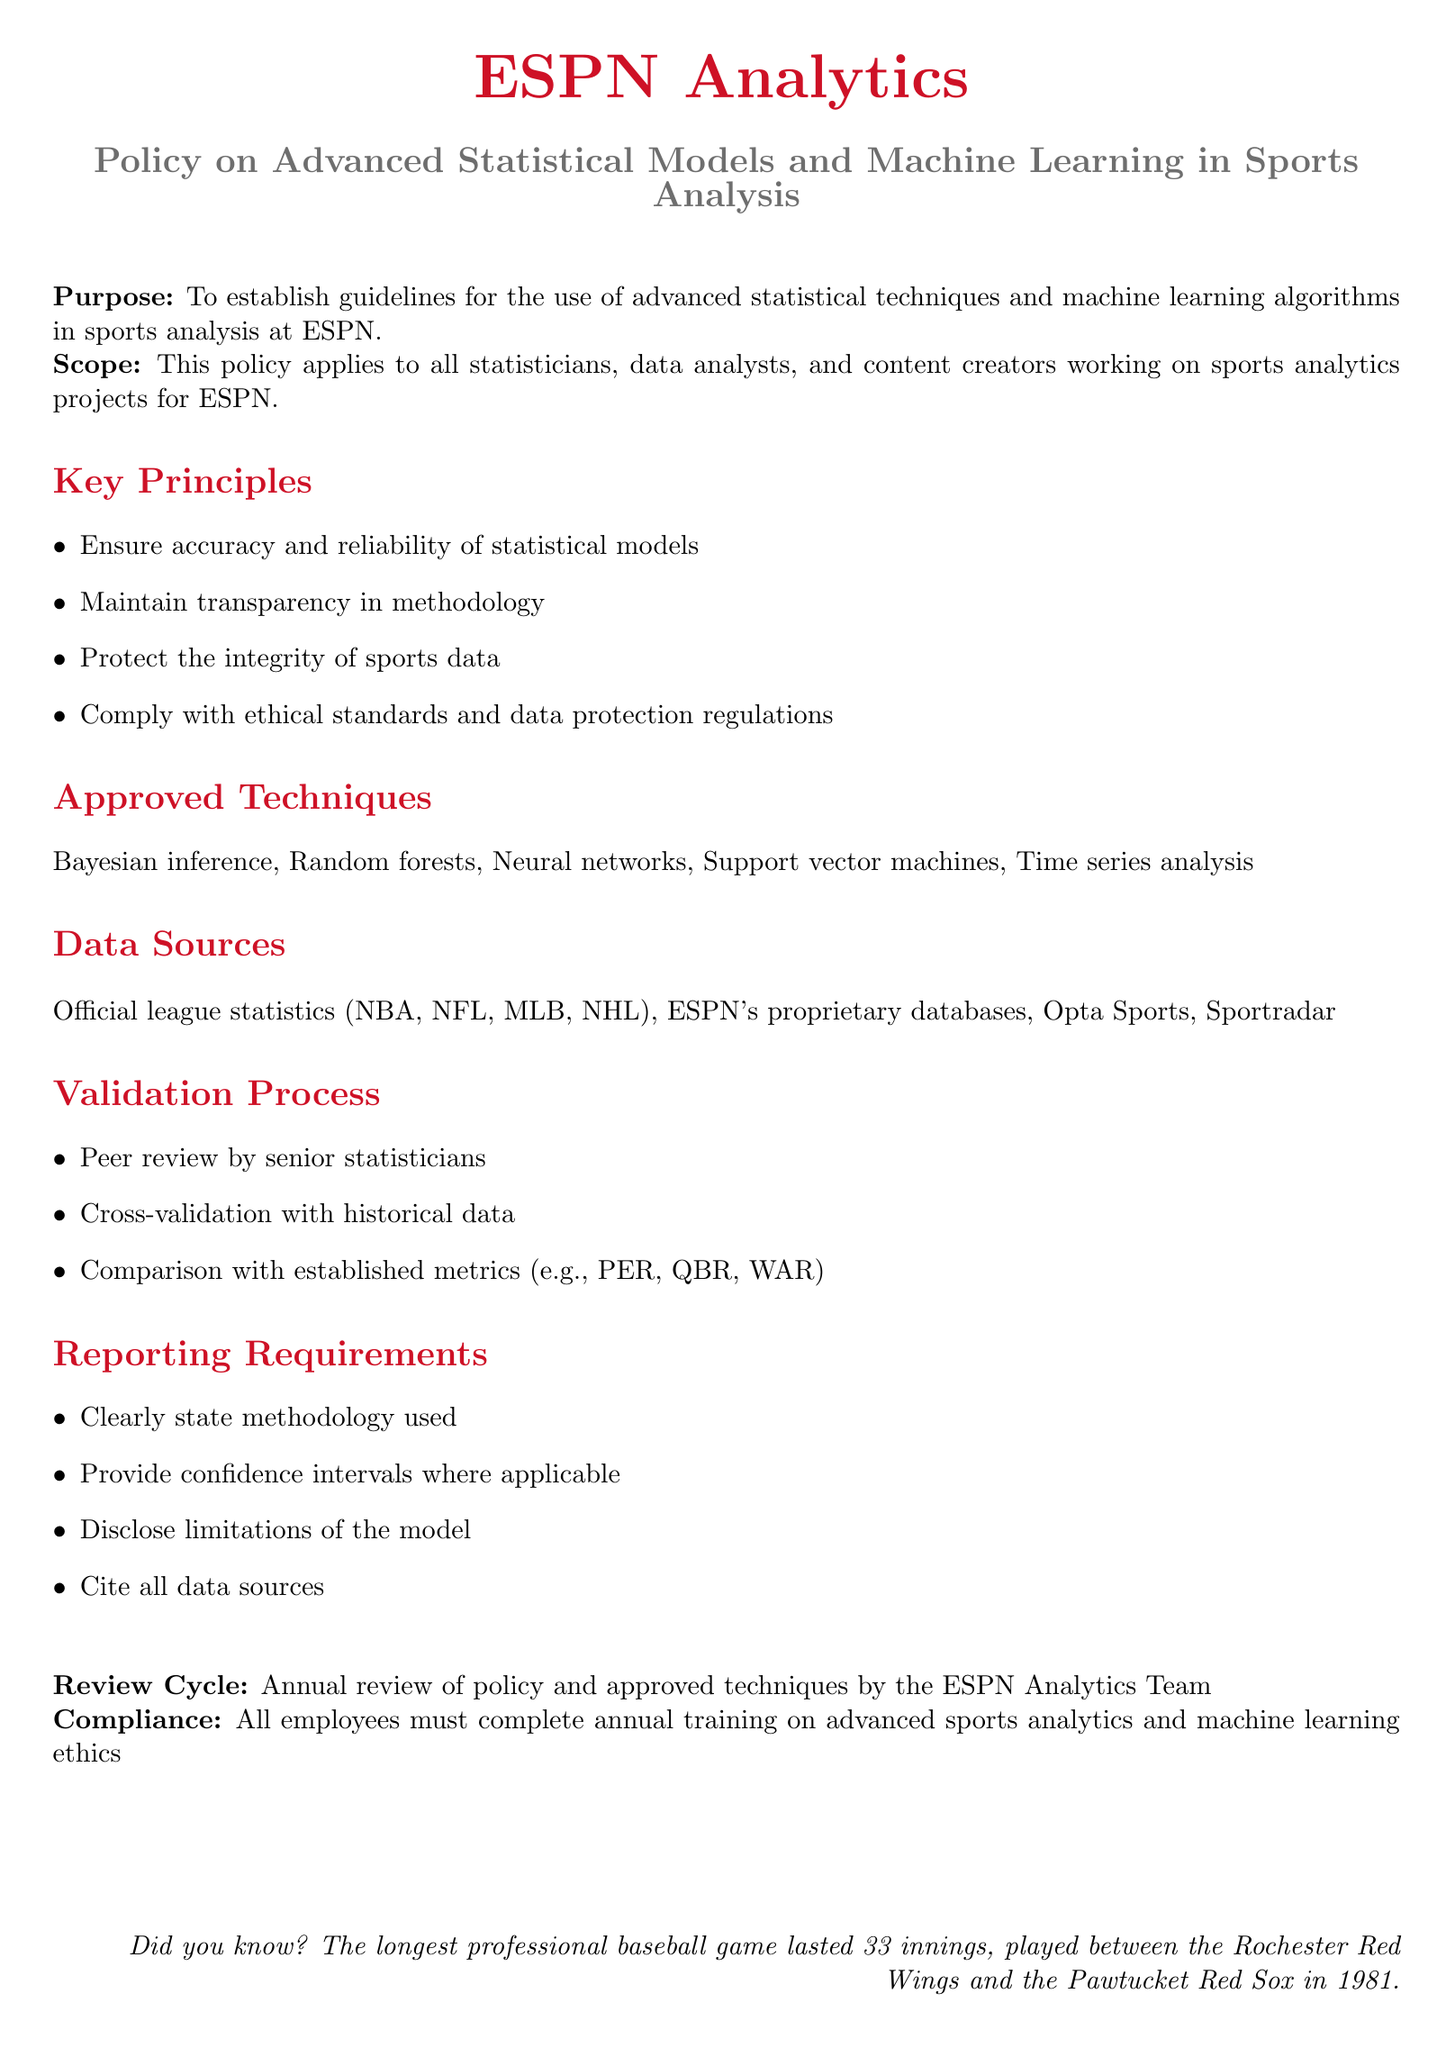What is the purpose of the policy? The purpose is to establish guidelines for the use of advanced statistical techniques and machine learning algorithms in sports analysis at ESPN.
Answer: To establish guidelines for the use of advanced statistical techniques and machine learning algorithms in sports analysis at ESPN Who does this policy apply to? The scope of the policy indicates that it applies to all statisticians, data analysts, and content creators working on sports analytics projects for ESPN.
Answer: All statisticians, data analysts, and content creators What is one approved technique mentioned in the document? The approved techniques section lists several methods, and one example is Bayesian inference.
Answer: Bayesian inference What type of data sources are included in the policy? The data sources section includes official league statistics, ESPN's proprietary databases, and others. One source mentioned is Opta Sports.
Answer: Opta Sports What is one requirement for reporting results? The reporting requirements state that methodology used must be clearly stated.
Answer: Clearly state methodology used How often will the policy be reviewed? The document specifies an annual review cycle for the policy and approved techniques.
Answer: Annual review What is the role of peer review in the validation process? The validation process includes peer review by senior statisticians to ensure model accuracy.
Answer: Peer review by senior statisticians What must all employees complete annually? The compliance section indicates that all employees must complete annual training on advanced sports analytics and machine learning ethics.
Answer: Annual training on advanced sports analytics and machine learning ethics 